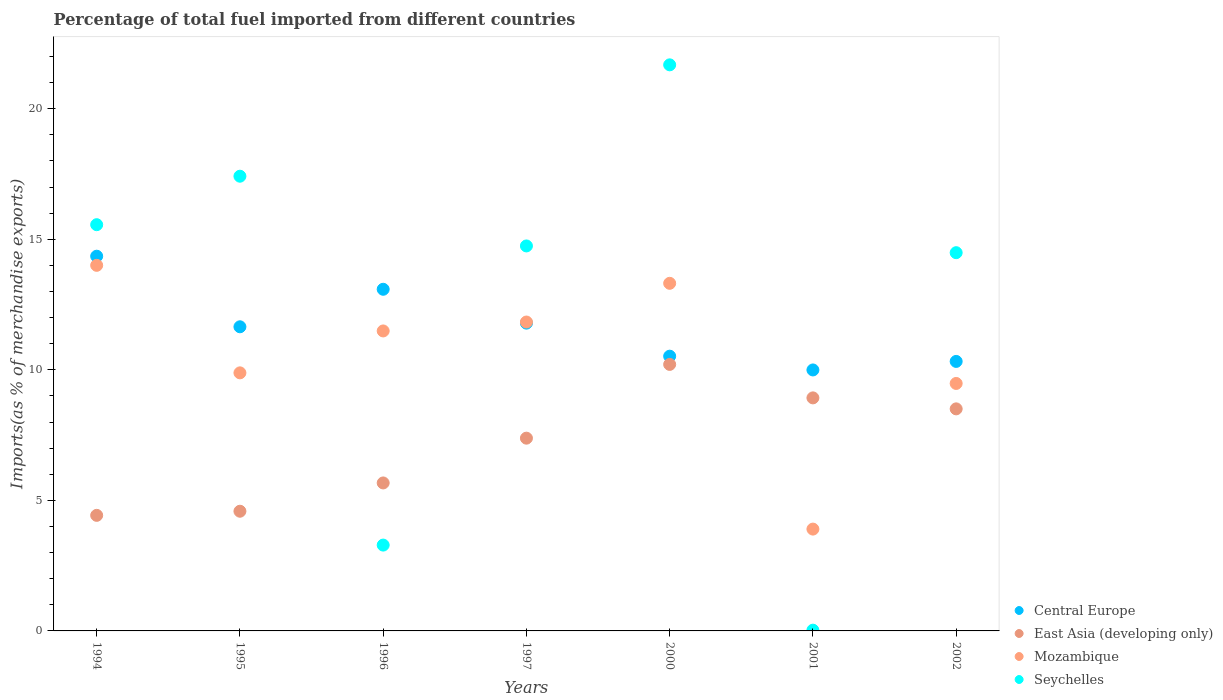How many different coloured dotlines are there?
Offer a very short reply. 4. What is the percentage of imports to different countries in Seychelles in 1997?
Offer a very short reply. 14.74. Across all years, what is the maximum percentage of imports to different countries in Mozambique?
Give a very brief answer. 14. Across all years, what is the minimum percentage of imports to different countries in East Asia (developing only)?
Provide a short and direct response. 4.43. In which year was the percentage of imports to different countries in Mozambique maximum?
Offer a terse response. 1994. In which year was the percentage of imports to different countries in Mozambique minimum?
Offer a terse response. 2001. What is the total percentage of imports to different countries in Mozambique in the graph?
Your answer should be very brief. 73.89. What is the difference between the percentage of imports to different countries in East Asia (developing only) in 1994 and that in 1997?
Keep it short and to the point. -2.96. What is the difference between the percentage of imports to different countries in Mozambique in 1995 and the percentage of imports to different countries in East Asia (developing only) in 1996?
Provide a short and direct response. 4.22. What is the average percentage of imports to different countries in Seychelles per year?
Make the answer very short. 12.46. In the year 1997, what is the difference between the percentage of imports to different countries in Seychelles and percentage of imports to different countries in Central Europe?
Offer a very short reply. 2.96. In how many years, is the percentage of imports to different countries in Central Europe greater than 21 %?
Keep it short and to the point. 0. What is the ratio of the percentage of imports to different countries in Central Europe in 1994 to that in 2002?
Your response must be concise. 1.39. What is the difference between the highest and the second highest percentage of imports to different countries in East Asia (developing only)?
Give a very brief answer. 1.28. What is the difference between the highest and the lowest percentage of imports to different countries in Central Europe?
Make the answer very short. 4.36. In how many years, is the percentage of imports to different countries in Central Europe greater than the average percentage of imports to different countries in Central Europe taken over all years?
Provide a succinct answer. 3. Is the percentage of imports to different countries in Seychelles strictly greater than the percentage of imports to different countries in East Asia (developing only) over the years?
Provide a succinct answer. No. How many dotlines are there?
Ensure brevity in your answer.  4. How many years are there in the graph?
Provide a short and direct response. 7. Does the graph contain any zero values?
Your response must be concise. No. Does the graph contain grids?
Make the answer very short. No. How many legend labels are there?
Your answer should be very brief. 4. What is the title of the graph?
Your answer should be very brief. Percentage of total fuel imported from different countries. What is the label or title of the Y-axis?
Provide a succinct answer. Imports(as % of merchandise exports). What is the Imports(as % of merchandise exports) of Central Europe in 1994?
Offer a terse response. 14.35. What is the Imports(as % of merchandise exports) in East Asia (developing only) in 1994?
Offer a very short reply. 4.43. What is the Imports(as % of merchandise exports) of Mozambique in 1994?
Your answer should be compact. 14. What is the Imports(as % of merchandise exports) of Seychelles in 1994?
Provide a short and direct response. 15.56. What is the Imports(as % of merchandise exports) of Central Europe in 1995?
Your response must be concise. 11.65. What is the Imports(as % of merchandise exports) in East Asia (developing only) in 1995?
Provide a short and direct response. 4.58. What is the Imports(as % of merchandise exports) in Mozambique in 1995?
Make the answer very short. 9.88. What is the Imports(as % of merchandise exports) of Seychelles in 1995?
Your answer should be very brief. 17.41. What is the Imports(as % of merchandise exports) of Central Europe in 1996?
Offer a terse response. 13.08. What is the Imports(as % of merchandise exports) of East Asia (developing only) in 1996?
Offer a terse response. 5.67. What is the Imports(as % of merchandise exports) of Mozambique in 1996?
Provide a succinct answer. 11.49. What is the Imports(as % of merchandise exports) of Seychelles in 1996?
Your answer should be very brief. 3.29. What is the Imports(as % of merchandise exports) of Central Europe in 1997?
Offer a very short reply. 11.79. What is the Imports(as % of merchandise exports) in East Asia (developing only) in 1997?
Your response must be concise. 7.38. What is the Imports(as % of merchandise exports) in Mozambique in 1997?
Provide a short and direct response. 11.83. What is the Imports(as % of merchandise exports) in Seychelles in 1997?
Keep it short and to the point. 14.74. What is the Imports(as % of merchandise exports) in Central Europe in 2000?
Your response must be concise. 10.52. What is the Imports(as % of merchandise exports) of East Asia (developing only) in 2000?
Ensure brevity in your answer.  10.21. What is the Imports(as % of merchandise exports) in Mozambique in 2000?
Keep it short and to the point. 13.31. What is the Imports(as % of merchandise exports) in Seychelles in 2000?
Offer a terse response. 21.68. What is the Imports(as % of merchandise exports) in Central Europe in 2001?
Provide a short and direct response. 9.99. What is the Imports(as % of merchandise exports) of East Asia (developing only) in 2001?
Ensure brevity in your answer.  8.93. What is the Imports(as % of merchandise exports) in Mozambique in 2001?
Offer a terse response. 3.9. What is the Imports(as % of merchandise exports) of Seychelles in 2001?
Provide a short and direct response. 0.03. What is the Imports(as % of merchandise exports) of Central Europe in 2002?
Your answer should be compact. 10.32. What is the Imports(as % of merchandise exports) in East Asia (developing only) in 2002?
Give a very brief answer. 8.5. What is the Imports(as % of merchandise exports) in Mozambique in 2002?
Your answer should be very brief. 9.48. What is the Imports(as % of merchandise exports) in Seychelles in 2002?
Provide a short and direct response. 14.49. Across all years, what is the maximum Imports(as % of merchandise exports) of Central Europe?
Offer a terse response. 14.35. Across all years, what is the maximum Imports(as % of merchandise exports) of East Asia (developing only)?
Give a very brief answer. 10.21. Across all years, what is the maximum Imports(as % of merchandise exports) of Mozambique?
Ensure brevity in your answer.  14. Across all years, what is the maximum Imports(as % of merchandise exports) of Seychelles?
Keep it short and to the point. 21.68. Across all years, what is the minimum Imports(as % of merchandise exports) of Central Europe?
Your answer should be very brief. 9.99. Across all years, what is the minimum Imports(as % of merchandise exports) of East Asia (developing only)?
Give a very brief answer. 4.43. Across all years, what is the minimum Imports(as % of merchandise exports) of Mozambique?
Your answer should be very brief. 3.9. Across all years, what is the minimum Imports(as % of merchandise exports) in Seychelles?
Your response must be concise. 0.03. What is the total Imports(as % of merchandise exports) of Central Europe in the graph?
Your response must be concise. 81.71. What is the total Imports(as % of merchandise exports) of East Asia (developing only) in the graph?
Ensure brevity in your answer.  49.7. What is the total Imports(as % of merchandise exports) of Mozambique in the graph?
Ensure brevity in your answer.  73.89. What is the total Imports(as % of merchandise exports) of Seychelles in the graph?
Your answer should be compact. 87.2. What is the difference between the Imports(as % of merchandise exports) of Central Europe in 1994 and that in 1995?
Ensure brevity in your answer.  2.7. What is the difference between the Imports(as % of merchandise exports) in East Asia (developing only) in 1994 and that in 1995?
Provide a succinct answer. -0.16. What is the difference between the Imports(as % of merchandise exports) of Mozambique in 1994 and that in 1995?
Provide a succinct answer. 4.12. What is the difference between the Imports(as % of merchandise exports) in Seychelles in 1994 and that in 1995?
Provide a succinct answer. -1.86. What is the difference between the Imports(as % of merchandise exports) of Central Europe in 1994 and that in 1996?
Your response must be concise. 1.27. What is the difference between the Imports(as % of merchandise exports) in East Asia (developing only) in 1994 and that in 1996?
Provide a short and direct response. -1.24. What is the difference between the Imports(as % of merchandise exports) of Mozambique in 1994 and that in 1996?
Ensure brevity in your answer.  2.51. What is the difference between the Imports(as % of merchandise exports) of Seychelles in 1994 and that in 1996?
Your answer should be compact. 12.27. What is the difference between the Imports(as % of merchandise exports) in Central Europe in 1994 and that in 1997?
Your answer should be very brief. 2.56. What is the difference between the Imports(as % of merchandise exports) in East Asia (developing only) in 1994 and that in 1997?
Provide a succinct answer. -2.96. What is the difference between the Imports(as % of merchandise exports) of Mozambique in 1994 and that in 1997?
Offer a terse response. 2.17. What is the difference between the Imports(as % of merchandise exports) of Seychelles in 1994 and that in 1997?
Offer a terse response. 0.81. What is the difference between the Imports(as % of merchandise exports) of Central Europe in 1994 and that in 2000?
Your answer should be very brief. 3.83. What is the difference between the Imports(as % of merchandise exports) in East Asia (developing only) in 1994 and that in 2000?
Your response must be concise. -5.78. What is the difference between the Imports(as % of merchandise exports) in Mozambique in 1994 and that in 2000?
Your answer should be very brief. 0.69. What is the difference between the Imports(as % of merchandise exports) of Seychelles in 1994 and that in 2000?
Provide a short and direct response. -6.12. What is the difference between the Imports(as % of merchandise exports) in Central Europe in 1994 and that in 2001?
Make the answer very short. 4.36. What is the difference between the Imports(as % of merchandise exports) in East Asia (developing only) in 1994 and that in 2001?
Keep it short and to the point. -4.5. What is the difference between the Imports(as % of merchandise exports) in Mozambique in 1994 and that in 2001?
Provide a short and direct response. 10.1. What is the difference between the Imports(as % of merchandise exports) in Seychelles in 1994 and that in 2001?
Offer a terse response. 15.53. What is the difference between the Imports(as % of merchandise exports) of Central Europe in 1994 and that in 2002?
Keep it short and to the point. 4.03. What is the difference between the Imports(as % of merchandise exports) of East Asia (developing only) in 1994 and that in 2002?
Provide a succinct answer. -4.08. What is the difference between the Imports(as % of merchandise exports) of Mozambique in 1994 and that in 2002?
Make the answer very short. 4.52. What is the difference between the Imports(as % of merchandise exports) in Seychelles in 1994 and that in 2002?
Give a very brief answer. 1.07. What is the difference between the Imports(as % of merchandise exports) of Central Europe in 1995 and that in 1996?
Keep it short and to the point. -1.44. What is the difference between the Imports(as % of merchandise exports) of East Asia (developing only) in 1995 and that in 1996?
Offer a terse response. -1.08. What is the difference between the Imports(as % of merchandise exports) of Mozambique in 1995 and that in 1996?
Keep it short and to the point. -1.6. What is the difference between the Imports(as % of merchandise exports) of Seychelles in 1995 and that in 1996?
Give a very brief answer. 14.13. What is the difference between the Imports(as % of merchandise exports) in Central Europe in 1995 and that in 1997?
Your answer should be very brief. -0.14. What is the difference between the Imports(as % of merchandise exports) in East Asia (developing only) in 1995 and that in 1997?
Provide a succinct answer. -2.8. What is the difference between the Imports(as % of merchandise exports) in Mozambique in 1995 and that in 1997?
Offer a very short reply. -1.95. What is the difference between the Imports(as % of merchandise exports) in Seychelles in 1995 and that in 1997?
Provide a succinct answer. 2.67. What is the difference between the Imports(as % of merchandise exports) of Central Europe in 1995 and that in 2000?
Ensure brevity in your answer.  1.13. What is the difference between the Imports(as % of merchandise exports) in East Asia (developing only) in 1995 and that in 2000?
Your answer should be compact. -5.62. What is the difference between the Imports(as % of merchandise exports) of Mozambique in 1995 and that in 2000?
Offer a very short reply. -3.43. What is the difference between the Imports(as % of merchandise exports) in Seychelles in 1995 and that in 2000?
Your answer should be compact. -4.27. What is the difference between the Imports(as % of merchandise exports) in Central Europe in 1995 and that in 2001?
Offer a terse response. 1.65. What is the difference between the Imports(as % of merchandise exports) of East Asia (developing only) in 1995 and that in 2001?
Provide a succinct answer. -4.34. What is the difference between the Imports(as % of merchandise exports) of Mozambique in 1995 and that in 2001?
Give a very brief answer. 5.98. What is the difference between the Imports(as % of merchandise exports) of Seychelles in 1995 and that in 2001?
Offer a terse response. 17.39. What is the difference between the Imports(as % of merchandise exports) in Central Europe in 1995 and that in 2002?
Offer a terse response. 1.33. What is the difference between the Imports(as % of merchandise exports) of East Asia (developing only) in 1995 and that in 2002?
Ensure brevity in your answer.  -3.92. What is the difference between the Imports(as % of merchandise exports) in Mozambique in 1995 and that in 2002?
Offer a very short reply. 0.41. What is the difference between the Imports(as % of merchandise exports) of Seychelles in 1995 and that in 2002?
Ensure brevity in your answer.  2.93. What is the difference between the Imports(as % of merchandise exports) of Central Europe in 1996 and that in 1997?
Your response must be concise. 1.3. What is the difference between the Imports(as % of merchandise exports) of East Asia (developing only) in 1996 and that in 1997?
Your answer should be compact. -1.71. What is the difference between the Imports(as % of merchandise exports) in Mozambique in 1996 and that in 1997?
Ensure brevity in your answer.  -0.34. What is the difference between the Imports(as % of merchandise exports) in Seychelles in 1996 and that in 1997?
Provide a succinct answer. -11.46. What is the difference between the Imports(as % of merchandise exports) in Central Europe in 1996 and that in 2000?
Offer a very short reply. 2.56. What is the difference between the Imports(as % of merchandise exports) of East Asia (developing only) in 1996 and that in 2000?
Give a very brief answer. -4.54. What is the difference between the Imports(as % of merchandise exports) of Mozambique in 1996 and that in 2000?
Ensure brevity in your answer.  -1.82. What is the difference between the Imports(as % of merchandise exports) of Seychelles in 1996 and that in 2000?
Your response must be concise. -18.39. What is the difference between the Imports(as % of merchandise exports) of Central Europe in 1996 and that in 2001?
Offer a terse response. 3.09. What is the difference between the Imports(as % of merchandise exports) of East Asia (developing only) in 1996 and that in 2001?
Your response must be concise. -3.26. What is the difference between the Imports(as % of merchandise exports) in Mozambique in 1996 and that in 2001?
Provide a short and direct response. 7.59. What is the difference between the Imports(as % of merchandise exports) of Seychelles in 1996 and that in 2001?
Ensure brevity in your answer.  3.26. What is the difference between the Imports(as % of merchandise exports) in Central Europe in 1996 and that in 2002?
Provide a succinct answer. 2.76. What is the difference between the Imports(as % of merchandise exports) in East Asia (developing only) in 1996 and that in 2002?
Offer a very short reply. -2.84. What is the difference between the Imports(as % of merchandise exports) in Mozambique in 1996 and that in 2002?
Give a very brief answer. 2.01. What is the difference between the Imports(as % of merchandise exports) in Seychelles in 1996 and that in 2002?
Give a very brief answer. -11.2. What is the difference between the Imports(as % of merchandise exports) in Central Europe in 1997 and that in 2000?
Offer a terse response. 1.27. What is the difference between the Imports(as % of merchandise exports) in East Asia (developing only) in 1997 and that in 2000?
Offer a very short reply. -2.82. What is the difference between the Imports(as % of merchandise exports) of Mozambique in 1997 and that in 2000?
Provide a succinct answer. -1.48. What is the difference between the Imports(as % of merchandise exports) of Seychelles in 1997 and that in 2000?
Provide a short and direct response. -6.94. What is the difference between the Imports(as % of merchandise exports) in Central Europe in 1997 and that in 2001?
Your response must be concise. 1.79. What is the difference between the Imports(as % of merchandise exports) of East Asia (developing only) in 1997 and that in 2001?
Give a very brief answer. -1.54. What is the difference between the Imports(as % of merchandise exports) in Mozambique in 1997 and that in 2001?
Keep it short and to the point. 7.93. What is the difference between the Imports(as % of merchandise exports) in Seychelles in 1997 and that in 2001?
Your answer should be very brief. 14.72. What is the difference between the Imports(as % of merchandise exports) in Central Europe in 1997 and that in 2002?
Provide a short and direct response. 1.47. What is the difference between the Imports(as % of merchandise exports) of East Asia (developing only) in 1997 and that in 2002?
Your response must be concise. -1.12. What is the difference between the Imports(as % of merchandise exports) in Mozambique in 1997 and that in 2002?
Your answer should be compact. 2.35. What is the difference between the Imports(as % of merchandise exports) of Seychelles in 1997 and that in 2002?
Make the answer very short. 0.26. What is the difference between the Imports(as % of merchandise exports) of Central Europe in 2000 and that in 2001?
Your response must be concise. 0.53. What is the difference between the Imports(as % of merchandise exports) of East Asia (developing only) in 2000 and that in 2001?
Offer a very short reply. 1.28. What is the difference between the Imports(as % of merchandise exports) of Mozambique in 2000 and that in 2001?
Offer a terse response. 9.41. What is the difference between the Imports(as % of merchandise exports) of Seychelles in 2000 and that in 2001?
Your answer should be very brief. 21.65. What is the difference between the Imports(as % of merchandise exports) in Central Europe in 2000 and that in 2002?
Give a very brief answer. 0.2. What is the difference between the Imports(as % of merchandise exports) in East Asia (developing only) in 2000 and that in 2002?
Provide a succinct answer. 1.7. What is the difference between the Imports(as % of merchandise exports) in Mozambique in 2000 and that in 2002?
Your response must be concise. 3.84. What is the difference between the Imports(as % of merchandise exports) of Seychelles in 2000 and that in 2002?
Provide a succinct answer. 7.19. What is the difference between the Imports(as % of merchandise exports) of Central Europe in 2001 and that in 2002?
Provide a short and direct response. -0.33. What is the difference between the Imports(as % of merchandise exports) of East Asia (developing only) in 2001 and that in 2002?
Your answer should be compact. 0.42. What is the difference between the Imports(as % of merchandise exports) of Mozambique in 2001 and that in 2002?
Provide a succinct answer. -5.58. What is the difference between the Imports(as % of merchandise exports) of Seychelles in 2001 and that in 2002?
Your answer should be compact. -14.46. What is the difference between the Imports(as % of merchandise exports) of Central Europe in 1994 and the Imports(as % of merchandise exports) of East Asia (developing only) in 1995?
Offer a very short reply. 9.77. What is the difference between the Imports(as % of merchandise exports) in Central Europe in 1994 and the Imports(as % of merchandise exports) in Mozambique in 1995?
Offer a very short reply. 4.47. What is the difference between the Imports(as % of merchandise exports) in Central Europe in 1994 and the Imports(as % of merchandise exports) in Seychelles in 1995?
Your answer should be very brief. -3.06. What is the difference between the Imports(as % of merchandise exports) of East Asia (developing only) in 1994 and the Imports(as % of merchandise exports) of Mozambique in 1995?
Offer a very short reply. -5.46. What is the difference between the Imports(as % of merchandise exports) in East Asia (developing only) in 1994 and the Imports(as % of merchandise exports) in Seychelles in 1995?
Give a very brief answer. -12.99. What is the difference between the Imports(as % of merchandise exports) of Mozambique in 1994 and the Imports(as % of merchandise exports) of Seychelles in 1995?
Give a very brief answer. -3.41. What is the difference between the Imports(as % of merchandise exports) of Central Europe in 1994 and the Imports(as % of merchandise exports) of East Asia (developing only) in 1996?
Offer a very short reply. 8.68. What is the difference between the Imports(as % of merchandise exports) in Central Europe in 1994 and the Imports(as % of merchandise exports) in Mozambique in 1996?
Your response must be concise. 2.86. What is the difference between the Imports(as % of merchandise exports) of Central Europe in 1994 and the Imports(as % of merchandise exports) of Seychelles in 1996?
Your response must be concise. 11.06. What is the difference between the Imports(as % of merchandise exports) in East Asia (developing only) in 1994 and the Imports(as % of merchandise exports) in Mozambique in 1996?
Provide a short and direct response. -7.06. What is the difference between the Imports(as % of merchandise exports) of East Asia (developing only) in 1994 and the Imports(as % of merchandise exports) of Seychelles in 1996?
Ensure brevity in your answer.  1.14. What is the difference between the Imports(as % of merchandise exports) in Mozambique in 1994 and the Imports(as % of merchandise exports) in Seychelles in 1996?
Your response must be concise. 10.71. What is the difference between the Imports(as % of merchandise exports) in Central Europe in 1994 and the Imports(as % of merchandise exports) in East Asia (developing only) in 1997?
Provide a succinct answer. 6.97. What is the difference between the Imports(as % of merchandise exports) in Central Europe in 1994 and the Imports(as % of merchandise exports) in Mozambique in 1997?
Provide a short and direct response. 2.52. What is the difference between the Imports(as % of merchandise exports) of Central Europe in 1994 and the Imports(as % of merchandise exports) of Seychelles in 1997?
Offer a terse response. -0.39. What is the difference between the Imports(as % of merchandise exports) in East Asia (developing only) in 1994 and the Imports(as % of merchandise exports) in Mozambique in 1997?
Keep it short and to the point. -7.4. What is the difference between the Imports(as % of merchandise exports) in East Asia (developing only) in 1994 and the Imports(as % of merchandise exports) in Seychelles in 1997?
Give a very brief answer. -10.32. What is the difference between the Imports(as % of merchandise exports) of Mozambique in 1994 and the Imports(as % of merchandise exports) of Seychelles in 1997?
Your answer should be compact. -0.74. What is the difference between the Imports(as % of merchandise exports) of Central Europe in 1994 and the Imports(as % of merchandise exports) of East Asia (developing only) in 2000?
Your answer should be very brief. 4.14. What is the difference between the Imports(as % of merchandise exports) in Central Europe in 1994 and the Imports(as % of merchandise exports) in Mozambique in 2000?
Offer a very short reply. 1.04. What is the difference between the Imports(as % of merchandise exports) of Central Europe in 1994 and the Imports(as % of merchandise exports) of Seychelles in 2000?
Make the answer very short. -7.33. What is the difference between the Imports(as % of merchandise exports) in East Asia (developing only) in 1994 and the Imports(as % of merchandise exports) in Mozambique in 2000?
Give a very brief answer. -8.89. What is the difference between the Imports(as % of merchandise exports) of East Asia (developing only) in 1994 and the Imports(as % of merchandise exports) of Seychelles in 2000?
Your response must be concise. -17.25. What is the difference between the Imports(as % of merchandise exports) of Mozambique in 1994 and the Imports(as % of merchandise exports) of Seychelles in 2000?
Make the answer very short. -7.68. What is the difference between the Imports(as % of merchandise exports) of Central Europe in 1994 and the Imports(as % of merchandise exports) of East Asia (developing only) in 2001?
Your answer should be compact. 5.43. What is the difference between the Imports(as % of merchandise exports) of Central Europe in 1994 and the Imports(as % of merchandise exports) of Mozambique in 2001?
Offer a very short reply. 10.45. What is the difference between the Imports(as % of merchandise exports) of Central Europe in 1994 and the Imports(as % of merchandise exports) of Seychelles in 2001?
Ensure brevity in your answer.  14.32. What is the difference between the Imports(as % of merchandise exports) of East Asia (developing only) in 1994 and the Imports(as % of merchandise exports) of Mozambique in 2001?
Offer a very short reply. 0.53. What is the difference between the Imports(as % of merchandise exports) of East Asia (developing only) in 1994 and the Imports(as % of merchandise exports) of Seychelles in 2001?
Make the answer very short. 4.4. What is the difference between the Imports(as % of merchandise exports) in Mozambique in 1994 and the Imports(as % of merchandise exports) in Seychelles in 2001?
Provide a succinct answer. 13.97. What is the difference between the Imports(as % of merchandise exports) of Central Europe in 1994 and the Imports(as % of merchandise exports) of East Asia (developing only) in 2002?
Make the answer very short. 5.85. What is the difference between the Imports(as % of merchandise exports) in Central Europe in 1994 and the Imports(as % of merchandise exports) in Mozambique in 2002?
Provide a short and direct response. 4.87. What is the difference between the Imports(as % of merchandise exports) in Central Europe in 1994 and the Imports(as % of merchandise exports) in Seychelles in 2002?
Offer a terse response. -0.13. What is the difference between the Imports(as % of merchandise exports) of East Asia (developing only) in 1994 and the Imports(as % of merchandise exports) of Mozambique in 2002?
Your answer should be compact. -5.05. What is the difference between the Imports(as % of merchandise exports) of East Asia (developing only) in 1994 and the Imports(as % of merchandise exports) of Seychelles in 2002?
Your response must be concise. -10.06. What is the difference between the Imports(as % of merchandise exports) in Mozambique in 1994 and the Imports(as % of merchandise exports) in Seychelles in 2002?
Your response must be concise. -0.48. What is the difference between the Imports(as % of merchandise exports) of Central Europe in 1995 and the Imports(as % of merchandise exports) of East Asia (developing only) in 1996?
Make the answer very short. 5.98. What is the difference between the Imports(as % of merchandise exports) in Central Europe in 1995 and the Imports(as % of merchandise exports) in Mozambique in 1996?
Ensure brevity in your answer.  0.16. What is the difference between the Imports(as % of merchandise exports) of Central Europe in 1995 and the Imports(as % of merchandise exports) of Seychelles in 1996?
Give a very brief answer. 8.36. What is the difference between the Imports(as % of merchandise exports) of East Asia (developing only) in 1995 and the Imports(as % of merchandise exports) of Mozambique in 1996?
Keep it short and to the point. -6.9. What is the difference between the Imports(as % of merchandise exports) of East Asia (developing only) in 1995 and the Imports(as % of merchandise exports) of Seychelles in 1996?
Your answer should be compact. 1.3. What is the difference between the Imports(as % of merchandise exports) in Mozambique in 1995 and the Imports(as % of merchandise exports) in Seychelles in 1996?
Give a very brief answer. 6.6. What is the difference between the Imports(as % of merchandise exports) in Central Europe in 1995 and the Imports(as % of merchandise exports) in East Asia (developing only) in 1997?
Make the answer very short. 4.27. What is the difference between the Imports(as % of merchandise exports) in Central Europe in 1995 and the Imports(as % of merchandise exports) in Mozambique in 1997?
Give a very brief answer. -0.18. What is the difference between the Imports(as % of merchandise exports) of Central Europe in 1995 and the Imports(as % of merchandise exports) of Seychelles in 1997?
Make the answer very short. -3.1. What is the difference between the Imports(as % of merchandise exports) of East Asia (developing only) in 1995 and the Imports(as % of merchandise exports) of Mozambique in 1997?
Offer a terse response. -7.25. What is the difference between the Imports(as % of merchandise exports) in East Asia (developing only) in 1995 and the Imports(as % of merchandise exports) in Seychelles in 1997?
Keep it short and to the point. -10.16. What is the difference between the Imports(as % of merchandise exports) of Mozambique in 1995 and the Imports(as % of merchandise exports) of Seychelles in 1997?
Offer a terse response. -4.86. What is the difference between the Imports(as % of merchandise exports) of Central Europe in 1995 and the Imports(as % of merchandise exports) of East Asia (developing only) in 2000?
Keep it short and to the point. 1.44. What is the difference between the Imports(as % of merchandise exports) in Central Europe in 1995 and the Imports(as % of merchandise exports) in Mozambique in 2000?
Keep it short and to the point. -1.66. What is the difference between the Imports(as % of merchandise exports) of Central Europe in 1995 and the Imports(as % of merchandise exports) of Seychelles in 2000?
Give a very brief answer. -10.03. What is the difference between the Imports(as % of merchandise exports) of East Asia (developing only) in 1995 and the Imports(as % of merchandise exports) of Mozambique in 2000?
Your answer should be compact. -8.73. What is the difference between the Imports(as % of merchandise exports) in East Asia (developing only) in 1995 and the Imports(as % of merchandise exports) in Seychelles in 2000?
Provide a succinct answer. -17.1. What is the difference between the Imports(as % of merchandise exports) of Mozambique in 1995 and the Imports(as % of merchandise exports) of Seychelles in 2000?
Make the answer very short. -11.8. What is the difference between the Imports(as % of merchandise exports) in Central Europe in 1995 and the Imports(as % of merchandise exports) in East Asia (developing only) in 2001?
Ensure brevity in your answer.  2.72. What is the difference between the Imports(as % of merchandise exports) in Central Europe in 1995 and the Imports(as % of merchandise exports) in Mozambique in 2001?
Provide a succinct answer. 7.75. What is the difference between the Imports(as % of merchandise exports) of Central Europe in 1995 and the Imports(as % of merchandise exports) of Seychelles in 2001?
Keep it short and to the point. 11.62. What is the difference between the Imports(as % of merchandise exports) in East Asia (developing only) in 1995 and the Imports(as % of merchandise exports) in Mozambique in 2001?
Keep it short and to the point. 0.68. What is the difference between the Imports(as % of merchandise exports) in East Asia (developing only) in 1995 and the Imports(as % of merchandise exports) in Seychelles in 2001?
Keep it short and to the point. 4.55. What is the difference between the Imports(as % of merchandise exports) of Mozambique in 1995 and the Imports(as % of merchandise exports) of Seychelles in 2001?
Offer a very short reply. 9.85. What is the difference between the Imports(as % of merchandise exports) in Central Europe in 1995 and the Imports(as % of merchandise exports) in East Asia (developing only) in 2002?
Your answer should be very brief. 3.14. What is the difference between the Imports(as % of merchandise exports) in Central Europe in 1995 and the Imports(as % of merchandise exports) in Mozambique in 2002?
Offer a very short reply. 2.17. What is the difference between the Imports(as % of merchandise exports) of Central Europe in 1995 and the Imports(as % of merchandise exports) of Seychelles in 2002?
Your response must be concise. -2.84. What is the difference between the Imports(as % of merchandise exports) of East Asia (developing only) in 1995 and the Imports(as % of merchandise exports) of Mozambique in 2002?
Ensure brevity in your answer.  -4.89. What is the difference between the Imports(as % of merchandise exports) of East Asia (developing only) in 1995 and the Imports(as % of merchandise exports) of Seychelles in 2002?
Your response must be concise. -9.9. What is the difference between the Imports(as % of merchandise exports) in Mozambique in 1995 and the Imports(as % of merchandise exports) in Seychelles in 2002?
Provide a short and direct response. -4.6. What is the difference between the Imports(as % of merchandise exports) in Central Europe in 1996 and the Imports(as % of merchandise exports) in East Asia (developing only) in 1997?
Your response must be concise. 5.7. What is the difference between the Imports(as % of merchandise exports) of Central Europe in 1996 and the Imports(as % of merchandise exports) of Mozambique in 1997?
Give a very brief answer. 1.25. What is the difference between the Imports(as % of merchandise exports) in Central Europe in 1996 and the Imports(as % of merchandise exports) in Seychelles in 1997?
Provide a short and direct response. -1.66. What is the difference between the Imports(as % of merchandise exports) in East Asia (developing only) in 1996 and the Imports(as % of merchandise exports) in Mozambique in 1997?
Provide a short and direct response. -6.16. What is the difference between the Imports(as % of merchandise exports) in East Asia (developing only) in 1996 and the Imports(as % of merchandise exports) in Seychelles in 1997?
Your response must be concise. -9.08. What is the difference between the Imports(as % of merchandise exports) in Mozambique in 1996 and the Imports(as % of merchandise exports) in Seychelles in 1997?
Keep it short and to the point. -3.26. What is the difference between the Imports(as % of merchandise exports) in Central Europe in 1996 and the Imports(as % of merchandise exports) in East Asia (developing only) in 2000?
Keep it short and to the point. 2.88. What is the difference between the Imports(as % of merchandise exports) of Central Europe in 1996 and the Imports(as % of merchandise exports) of Mozambique in 2000?
Offer a very short reply. -0.23. What is the difference between the Imports(as % of merchandise exports) in Central Europe in 1996 and the Imports(as % of merchandise exports) in Seychelles in 2000?
Keep it short and to the point. -8.6. What is the difference between the Imports(as % of merchandise exports) in East Asia (developing only) in 1996 and the Imports(as % of merchandise exports) in Mozambique in 2000?
Provide a succinct answer. -7.65. What is the difference between the Imports(as % of merchandise exports) in East Asia (developing only) in 1996 and the Imports(as % of merchandise exports) in Seychelles in 2000?
Offer a very short reply. -16.01. What is the difference between the Imports(as % of merchandise exports) in Mozambique in 1996 and the Imports(as % of merchandise exports) in Seychelles in 2000?
Give a very brief answer. -10.19. What is the difference between the Imports(as % of merchandise exports) in Central Europe in 1996 and the Imports(as % of merchandise exports) in East Asia (developing only) in 2001?
Your answer should be very brief. 4.16. What is the difference between the Imports(as % of merchandise exports) in Central Europe in 1996 and the Imports(as % of merchandise exports) in Mozambique in 2001?
Provide a short and direct response. 9.18. What is the difference between the Imports(as % of merchandise exports) of Central Europe in 1996 and the Imports(as % of merchandise exports) of Seychelles in 2001?
Ensure brevity in your answer.  13.06. What is the difference between the Imports(as % of merchandise exports) in East Asia (developing only) in 1996 and the Imports(as % of merchandise exports) in Mozambique in 2001?
Offer a terse response. 1.77. What is the difference between the Imports(as % of merchandise exports) in East Asia (developing only) in 1996 and the Imports(as % of merchandise exports) in Seychelles in 2001?
Provide a short and direct response. 5.64. What is the difference between the Imports(as % of merchandise exports) of Mozambique in 1996 and the Imports(as % of merchandise exports) of Seychelles in 2001?
Give a very brief answer. 11.46. What is the difference between the Imports(as % of merchandise exports) of Central Europe in 1996 and the Imports(as % of merchandise exports) of East Asia (developing only) in 2002?
Your response must be concise. 4.58. What is the difference between the Imports(as % of merchandise exports) of Central Europe in 1996 and the Imports(as % of merchandise exports) of Mozambique in 2002?
Offer a very short reply. 3.61. What is the difference between the Imports(as % of merchandise exports) of Central Europe in 1996 and the Imports(as % of merchandise exports) of Seychelles in 2002?
Provide a short and direct response. -1.4. What is the difference between the Imports(as % of merchandise exports) in East Asia (developing only) in 1996 and the Imports(as % of merchandise exports) in Mozambique in 2002?
Your response must be concise. -3.81. What is the difference between the Imports(as % of merchandise exports) in East Asia (developing only) in 1996 and the Imports(as % of merchandise exports) in Seychelles in 2002?
Provide a short and direct response. -8.82. What is the difference between the Imports(as % of merchandise exports) in Mozambique in 1996 and the Imports(as % of merchandise exports) in Seychelles in 2002?
Make the answer very short. -3. What is the difference between the Imports(as % of merchandise exports) of Central Europe in 1997 and the Imports(as % of merchandise exports) of East Asia (developing only) in 2000?
Offer a very short reply. 1.58. What is the difference between the Imports(as % of merchandise exports) of Central Europe in 1997 and the Imports(as % of merchandise exports) of Mozambique in 2000?
Provide a short and direct response. -1.52. What is the difference between the Imports(as % of merchandise exports) of Central Europe in 1997 and the Imports(as % of merchandise exports) of Seychelles in 2000?
Make the answer very short. -9.89. What is the difference between the Imports(as % of merchandise exports) in East Asia (developing only) in 1997 and the Imports(as % of merchandise exports) in Mozambique in 2000?
Offer a terse response. -5.93. What is the difference between the Imports(as % of merchandise exports) in East Asia (developing only) in 1997 and the Imports(as % of merchandise exports) in Seychelles in 2000?
Your answer should be very brief. -14.3. What is the difference between the Imports(as % of merchandise exports) of Mozambique in 1997 and the Imports(as % of merchandise exports) of Seychelles in 2000?
Your response must be concise. -9.85. What is the difference between the Imports(as % of merchandise exports) of Central Europe in 1997 and the Imports(as % of merchandise exports) of East Asia (developing only) in 2001?
Your answer should be very brief. 2.86. What is the difference between the Imports(as % of merchandise exports) of Central Europe in 1997 and the Imports(as % of merchandise exports) of Mozambique in 2001?
Offer a terse response. 7.89. What is the difference between the Imports(as % of merchandise exports) in Central Europe in 1997 and the Imports(as % of merchandise exports) in Seychelles in 2001?
Ensure brevity in your answer.  11.76. What is the difference between the Imports(as % of merchandise exports) of East Asia (developing only) in 1997 and the Imports(as % of merchandise exports) of Mozambique in 2001?
Your response must be concise. 3.48. What is the difference between the Imports(as % of merchandise exports) in East Asia (developing only) in 1997 and the Imports(as % of merchandise exports) in Seychelles in 2001?
Keep it short and to the point. 7.35. What is the difference between the Imports(as % of merchandise exports) of Mozambique in 1997 and the Imports(as % of merchandise exports) of Seychelles in 2001?
Give a very brief answer. 11.8. What is the difference between the Imports(as % of merchandise exports) in Central Europe in 1997 and the Imports(as % of merchandise exports) in East Asia (developing only) in 2002?
Give a very brief answer. 3.28. What is the difference between the Imports(as % of merchandise exports) of Central Europe in 1997 and the Imports(as % of merchandise exports) of Mozambique in 2002?
Provide a succinct answer. 2.31. What is the difference between the Imports(as % of merchandise exports) in Central Europe in 1997 and the Imports(as % of merchandise exports) in Seychelles in 2002?
Make the answer very short. -2.7. What is the difference between the Imports(as % of merchandise exports) in East Asia (developing only) in 1997 and the Imports(as % of merchandise exports) in Mozambique in 2002?
Offer a terse response. -2.1. What is the difference between the Imports(as % of merchandise exports) in East Asia (developing only) in 1997 and the Imports(as % of merchandise exports) in Seychelles in 2002?
Offer a very short reply. -7.1. What is the difference between the Imports(as % of merchandise exports) in Mozambique in 1997 and the Imports(as % of merchandise exports) in Seychelles in 2002?
Provide a succinct answer. -2.66. What is the difference between the Imports(as % of merchandise exports) in Central Europe in 2000 and the Imports(as % of merchandise exports) in East Asia (developing only) in 2001?
Offer a very short reply. 1.6. What is the difference between the Imports(as % of merchandise exports) of Central Europe in 2000 and the Imports(as % of merchandise exports) of Mozambique in 2001?
Offer a terse response. 6.62. What is the difference between the Imports(as % of merchandise exports) of Central Europe in 2000 and the Imports(as % of merchandise exports) of Seychelles in 2001?
Keep it short and to the point. 10.49. What is the difference between the Imports(as % of merchandise exports) in East Asia (developing only) in 2000 and the Imports(as % of merchandise exports) in Mozambique in 2001?
Make the answer very short. 6.31. What is the difference between the Imports(as % of merchandise exports) of East Asia (developing only) in 2000 and the Imports(as % of merchandise exports) of Seychelles in 2001?
Offer a very short reply. 10.18. What is the difference between the Imports(as % of merchandise exports) in Mozambique in 2000 and the Imports(as % of merchandise exports) in Seychelles in 2001?
Make the answer very short. 13.28. What is the difference between the Imports(as % of merchandise exports) of Central Europe in 2000 and the Imports(as % of merchandise exports) of East Asia (developing only) in 2002?
Provide a succinct answer. 2.02. What is the difference between the Imports(as % of merchandise exports) of Central Europe in 2000 and the Imports(as % of merchandise exports) of Mozambique in 2002?
Offer a very short reply. 1.04. What is the difference between the Imports(as % of merchandise exports) in Central Europe in 2000 and the Imports(as % of merchandise exports) in Seychelles in 2002?
Provide a succinct answer. -3.96. What is the difference between the Imports(as % of merchandise exports) in East Asia (developing only) in 2000 and the Imports(as % of merchandise exports) in Mozambique in 2002?
Provide a succinct answer. 0.73. What is the difference between the Imports(as % of merchandise exports) in East Asia (developing only) in 2000 and the Imports(as % of merchandise exports) in Seychelles in 2002?
Ensure brevity in your answer.  -4.28. What is the difference between the Imports(as % of merchandise exports) in Mozambique in 2000 and the Imports(as % of merchandise exports) in Seychelles in 2002?
Your answer should be compact. -1.17. What is the difference between the Imports(as % of merchandise exports) of Central Europe in 2001 and the Imports(as % of merchandise exports) of East Asia (developing only) in 2002?
Provide a succinct answer. 1.49. What is the difference between the Imports(as % of merchandise exports) in Central Europe in 2001 and the Imports(as % of merchandise exports) in Mozambique in 2002?
Your response must be concise. 0.52. What is the difference between the Imports(as % of merchandise exports) of Central Europe in 2001 and the Imports(as % of merchandise exports) of Seychelles in 2002?
Your response must be concise. -4.49. What is the difference between the Imports(as % of merchandise exports) of East Asia (developing only) in 2001 and the Imports(as % of merchandise exports) of Mozambique in 2002?
Offer a very short reply. -0.55. What is the difference between the Imports(as % of merchandise exports) of East Asia (developing only) in 2001 and the Imports(as % of merchandise exports) of Seychelles in 2002?
Give a very brief answer. -5.56. What is the difference between the Imports(as % of merchandise exports) of Mozambique in 2001 and the Imports(as % of merchandise exports) of Seychelles in 2002?
Your answer should be compact. -10.59. What is the average Imports(as % of merchandise exports) of Central Europe per year?
Your answer should be compact. 11.67. What is the average Imports(as % of merchandise exports) in East Asia (developing only) per year?
Your answer should be compact. 7.1. What is the average Imports(as % of merchandise exports) in Mozambique per year?
Make the answer very short. 10.56. What is the average Imports(as % of merchandise exports) of Seychelles per year?
Offer a terse response. 12.46. In the year 1994, what is the difference between the Imports(as % of merchandise exports) in Central Europe and Imports(as % of merchandise exports) in East Asia (developing only)?
Keep it short and to the point. 9.92. In the year 1994, what is the difference between the Imports(as % of merchandise exports) in Central Europe and Imports(as % of merchandise exports) in Mozambique?
Keep it short and to the point. 0.35. In the year 1994, what is the difference between the Imports(as % of merchandise exports) in Central Europe and Imports(as % of merchandise exports) in Seychelles?
Give a very brief answer. -1.21. In the year 1994, what is the difference between the Imports(as % of merchandise exports) in East Asia (developing only) and Imports(as % of merchandise exports) in Mozambique?
Ensure brevity in your answer.  -9.58. In the year 1994, what is the difference between the Imports(as % of merchandise exports) in East Asia (developing only) and Imports(as % of merchandise exports) in Seychelles?
Make the answer very short. -11.13. In the year 1994, what is the difference between the Imports(as % of merchandise exports) in Mozambique and Imports(as % of merchandise exports) in Seychelles?
Provide a short and direct response. -1.56. In the year 1995, what is the difference between the Imports(as % of merchandise exports) in Central Europe and Imports(as % of merchandise exports) in East Asia (developing only)?
Make the answer very short. 7.06. In the year 1995, what is the difference between the Imports(as % of merchandise exports) in Central Europe and Imports(as % of merchandise exports) in Mozambique?
Make the answer very short. 1.76. In the year 1995, what is the difference between the Imports(as % of merchandise exports) in Central Europe and Imports(as % of merchandise exports) in Seychelles?
Your answer should be compact. -5.77. In the year 1995, what is the difference between the Imports(as % of merchandise exports) of East Asia (developing only) and Imports(as % of merchandise exports) of Mozambique?
Your response must be concise. -5.3. In the year 1995, what is the difference between the Imports(as % of merchandise exports) of East Asia (developing only) and Imports(as % of merchandise exports) of Seychelles?
Ensure brevity in your answer.  -12.83. In the year 1995, what is the difference between the Imports(as % of merchandise exports) in Mozambique and Imports(as % of merchandise exports) in Seychelles?
Give a very brief answer. -7.53. In the year 1996, what is the difference between the Imports(as % of merchandise exports) in Central Europe and Imports(as % of merchandise exports) in East Asia (developing only)?
Your answer should be very brief. 7.42. In the year 1996, what is the difference between the Imports(as % of merchandise exports) of Central Europe and Imports(as % of merchandise exports) of Mozambique?
Offer a very short reply. 1.6. In the year 1996, what is the difference between the Imports(as % of merchandise exports) in Central Europe and Imports(as % of merchandise exports) in Seychelles?
Provide a succinct answer. 9.8. In the year 1996, what is the difference between the Imports(as % of merchandise exports) in East Asia (developing only) and Imports(as % of merchandise exports) in Mozambique?
Make the answer very short. -5.82. In the year 1996, what is the difference between the Imports(as % of merchandise exports) of East Asia (developing only) and Imports(as % of merchandise exports) of Seychelles?
Provide a short and direct response. 2.38. In the year 1996, what is the difference between the Imports(as % of merchandise exports) of Mozambique and Imports(as % of merchandise exports) of Seychelles?
Your answer should be compact. 8.2. In the year 1997, what is the difference between the Imports(as % of merchandise exports) in Central Europe and Imports(as % of merchandise exports) in East Asia (developing only)?
Provide a succinct answer. 4.41. In the year 1997, what is the difference between the Imports(as % of merchandise exports) in Central Europe and Imports(as % of merchandise exports) in Mozambique?
Offer a terse response. -0.04. In the year 1997, what is the difference between the Imports(as % of merchandise exports) in Central Europe and Imports(as % of merchandise exports) in Seychelles?
Keep it short and to the point. -2.96. In the year 1997, what is the difference between the Imports(as % of merchandise exports) in East Asia (developing only) and Imports(as % of merchandise exports) in Mozambique?
Provide a short and direct response. -4.45. In the year 1997, what is the difference between the Imports(as % of merchandise exports) in East Asia (developing only) and Imports(as % of merchandise exports) in Seychelles?
Your answer should be compact. -7.36. In the year 1997, what is the difference between the Imports(as % of merchandise exports) of Mozambique and Imports(as % of merchandise exports) of Seychelles?
Offer a terse response. -2.91. In the year 2000, what is the difference between the Imports(as % of merchandise exports) of Central Europe and Imports(as % of merchandise exports) of East Asia (developing only)?
Make the answer very short. 0.32. In the year 2000, what is the difference between the Imports(as % of merchandise exports) in Central Europe and Imports(as % of merchandise exports) in Mozambique?
Your answer should be very brief. -2.79. In the year 2000, what is the difference between the Imports(as % of merchandise exports) of Central Europe and Imports(as % of merchandise exports) of Seychelles?
Provide a short and direct response. -11.16. In the year 2000, what is the difference between the Imports(as % of merchandise exports) of East Asia (developing only) and Imports(as % of merchandise exports) of Mozambique?
Give a very brief answer. -3.11. In the year 2000, what is the difference between the Imports(as % of merchandise exports) of East Asia (developing only) and Imports(as % of merchandise exports) of Seychelles?
Provide a short and direct response. -11.47. In the year 2000, what is the difference between the Imports(as % of merchandise exports) of Mozambique and Imports(as % of merchandise exports) of Seychelles?
Make the answer very short. -8.37. In the year 2001, what is the difference between the Imports(as % of merchandise exports) in Central Europe and Imports(as % of merchandise exports) in East Asia (developing only)?
Give a very brief answer. 1.07. In the year 2001, what is the difference between the Imports(as % of merchandise exports) in Central Europe and Imports(as % of merchandise exports) in Mozambique?
Give a very brief answer. 6.1. In the year 2001, what is the difference between the Imports(as % of merchandise exports) of Central Europe and Imports(as % of merchandise exports) of Seychelles?
Your response must be concise. 9.97. In the year 2001, what is the difference between the Imports(as % of merchandise exports) in East Asia (developing only) and Imports(as % of merchandise exports) in Mozambique?
Give a very brief answer. 5.03. In the year 2001, what is the difference between the Imports(as % of merchandise exports) in East Asia (developing only) and Imports(as % of merchandise exports) in Seychelles?
Your response must be concise. 8.9. In the year 2001, what is the difference between the Imports(as % of merchandise exports) in Mozambique and Imports(as % of merchandise exports) in Seychelles?
Your response must be concise. 3.87. In the year 2002, what is the difference between the Imports(as % of merchandise exports) in Central Europe and Imports(as % of merchandise exports) in East Asia (developing only)?
Your answer should be very brief. 1.82. In the year 2002, what is the difference between the Imports(as % of merchandise exports) of Central Europe and Imports(as % of merchandise exports) of Mozambique?
Your answer should be compact. 0.84. In the year 2002, what is the difference between the Imports(as % of merchandise exports) of Central Europe and Imports(as % of merchandise exports) of Seychelles?
Your answer should be compact. -4.16. In the year 2002, what is the difference between the Imports(as % of merchandise exports) of East Asia (developing only) and Imports(as % of merchandise exports) of Mozambique?
Your answer should be compact. -0.97. In the year 2002, what is the difference between the Imports(as % of merchandise exports) of East Asia (developing only) and Imports(as % of merchandise exports) of Seychelles?
Your answer should be very brief. -5.98. In the year 2002, what is the difference between the Imports(as % of merchandise exports) of Mozambique and Imports(as % of merchandise exports) of Seychelles?
Ensure brevity in your answer.  -5.01. What is the ratio of the Imports(as % of merchandise exports) in Central Europe in 1994 to that in 1995?
Make the answer very short. 1.23. What is the ratio of the Imports(as % of merchandise exports) of East Asia (developing only) in 1994 to that in 1995?
Offer a very short reply. 0.97. What is the ratio of the Imports(as % of merchandise exports) of Mozambique in 1994 to that in 1995?
Provide a succinct answer. 1.42. What is the ratio of the Imports(as % of merchandise exports) of Seychelles in 1994 to that in 1995?
Make the answer very short. 0.89. What is the ratio of the Imports(as % of merchandise exports) of Central Europe in 1994 to that in 1996?
Your response must be concise. 1.1. What is the ratio of the Imports(as % of merchandise exports) in East Asia (developing only) in 1994 to that in 1996?
Your response must be concise. 0.78. What is the ratio of the Imports(as % of merchandise exports) in Mozambique in 1994 to that in 1996?
Your answer should be very brief. 1.22. What is the ratio of the Imports(as % of merchandise exports) of Seychelles in 1994 to that in 1996?
Offer a very short reply. 4.73. What is the ratio of the Imports(as % of merchandise exports) in Central Europe in 1994 to that in 1997?
Keep it short and to the point. 1.22. What is the ratio of the Imports(as % of merchandise exports) in East Asia (developing only) in 1994 to that in 1997?
Provide a short and direct response. 0.6. What is the ratio of the Imports(as % of merchandise exports) of Mozambique in 1994 to that in 1997?
Your answer should be very brief. 1.18. What is the ratio of the Imports(as % of merchandise exports) of Seychelles in 1994 to that in 1997?
Give a very brief answer. 1.06. What is the ratio of the Imports(as % of merchandise exports) in Central Europe in 1994 to that in 2000?
Provide a succinct answer. 1.36. What is the ratio of the Imports(as % of merchandise exports) of East Asia (developing only) in 1994 to that in 2000?
Give a very brief answer. 0.43. What is the ratio of the Imports(as % of merchandise exports) of Mozambique in 1994 to that in 2000?
Provide a succinct answer. 1.05. What is the ratio of the Imports(as % of merchandise exports) of Seychelles in 1994 to that in 2000?
Make the answer very short. 0.72. What is the ratio of the Imports(as % of merchandise exports) in Central Europe in 1994 to that in 2001?
Keep it short and to the point. 1.44. What is the ratio of the Imports(as % of merchandise exports) of East Asia (developing only) in 1994 to that in 2001?
Your response must be concise. 0.5. What is the ratio of the Imports(as % of merchandise exports) in Mozambique in 1994 to that in 2001?
Give a very brief answer. 3.59. What is the ratio of the Imports(as % of merchandise exports) in Seychelles in 1994 to that in 2001?
Provide a short and direct response. 536.76. What is the ratio of the Imports(as % of merchandise exports) in Central Europe in 1994 to that in 2002?
Offer a very short reply. 1.39. What is the ratio of the Imports(as % of merchandise exports) in East Asia (developing only) in 1994 to that in 2002?
Provide a succinct answer. 0.52. What is the ratio of the Imports(as % of merchandise exports) in Mozambique in 1994 to that in 2002?
Your answer should be compact. 1.48. What is the ratio of the Imports(as % of merchandise exports) in Seychelles in 1994 to that in 2002?
Make the answer very short. 1.07. What is the ratio of the Imports(as % of merchandise exports) in Central Europe in 1995 to that in 1996?
Your answer should be compact. 0.89. What is the ratio of the Imports(as % of merchandise exports) of East Asia (developing only) in 1995 to that in 1996?
Offer a terse response. 0.81. What is the ratio of the Imports(as % of merchandise exports) in Mozambique in 1995 to that in 1996?
Ensure brevity in your answer.  0.86. What is the ratio of the Imports(as % of merchandise exports) of Seychelles in 1995 to that in 1996?
Your answer should be very brief. 5.3. What is the ratio of the Imports(as % of merchandise exports) of Central Europe in 1995 to that in 1997?
Your response must be concise. 0.99. What is the ratio of the Imports(as % of merchandise exports) in East Asia (developing only) in 1995 to that in 1997?
Your answer should be very brief. 0.62. What is the ratio of the Imports(as % of merchandise exports) in Mozambique in 1995 to that in 1997?
Your answer should be very brief. 0.84. What is the ratio of the Imports(as % of merchandise exports) in Seychelles in 1995 to that in 1997?
Give a very brief answer. 1.18. What is the ratio of the Imports(as % of merchandise exports) in Central Europe in 1995 to that in 2000?
Give a very brief answer. 1.11. What is the ratio of the Imports(as % of merchandise exports) of East Asia (developing only) in 1995 to that in 2000?
Provide a succinct answer. 0.45. What is the ratio of the Imports(as % of merchandise exports) of Mozambique in 1995 to that in 2000?
Keep it short and to the point. 0.74. What is the ratio of the Imports(as % of merchandise exports) of Seychelles in 1995 to that in 2000?
Offer a very short reply. 0.8. What is the ratio of the Imports(as % of merchandise exports) of Central Europe in 1995 to that in 2001?
Your answer should be very brief. 1.17. What is the ratio of the Imports(as % of merchandise exports) of East Asia (developing only) in 1995 to that in 2001?
Offer a terse response. 0.51. What is the ratio of the Imports(as % of merchandise exports) of Mozambique in 1995 to that in 2001?
Offer a very short reply. 2.53. What is the ratio of the Imports(as % of merchandise exports) of Seychelles in 1995 to that in 2001?
Offer a terse response. 600.81. What is the ratio of the Imports(as % of merchandise exports) in Central Europe in 1995 to that in 2002?
Your answer should be compact. 1.13. What is the ratio of the Imports(as % of merchandise exports) of East Asia (developing only) in 1995 to that in 2002?
Keep it short and to the point. 0.54. What is the ratio of the Imports(as % of merchandise exports) of Mozambique in 1995 to that in 2002?
Make the answer very short. 1.04. What is the ratio of the Imports(as % of merchandise exports) of Seychelles in 1995 to that in 2002?
Give a very brief answer. 1.2. What is the ratio of the Imports(as % of merchandise exports) in Central Europe in 1996 to that in 1997?
Your response must be concise. 1.11. What is the ratio of the Imports(as % of merchandise exports) in East Asia (developing only) in 1996 to that in 1997?
Offer a very short reply. 0.77. What is the ratio of the Imports(as % of merchandise exports) of Mozambique in 1996 to that in 1997?
Offer a very short reply. 0.97. What is the ratio of the Imports(as % of merchandise exports) in Seychelles in 1996 to that in 1997?
Provide a short and direct response. 0.22. What is the ratio of the Imports(as % of merchandise exports) of Central Europe in 1996 to that in 2000?
Ensure brevity in your answer.  1.24. What is the ratio of the Imports(as % of merchandise exports) in East Asia (developing only) in 1996 to that in 2000?
Keep it short and to the point. 0.56. What is the ratio of the Imports(as % of merchandise exports) of Mozambique in 1996 to that in 2000?
Provide a short and direct response. 0.86. What is the ratio of the Imports(as % of merchandise exports) in Seychelles in 1996 to that in 2000?
Give a very brief answer. 0.15. What is the ratio of the Imports(as % of merchandise exports) of Central Europe in 1996 to that in 2001?
Keep it short and to the point. 1.31. What is the ratio of the Imports(as % of merchandise exports) of East Asia (developing only) in 1996 to that in 2001?
Give a very brief answer. 0.64. What is the ratio of the Imports(as % of merchandise exports) in Mozambique in 1996 to that in 2001?
Make the answer very short. 2.95. What is the ratio of the Imports(as % of merchandise exports) in Seychelles in 1996 to that in 2001?
Make the answer very short. 113.41. What is the ratio of the Imports(as % of merchandise exports) in Central Europe in 1996 to that in 2002?
Provide a short and direct response. 1.27. What is the ratio of the Imports(as % of merchandise exports) of East Asia (developing only) in 1996 to that in 2002?
Offer a terse response. 0.67. What is the ratio of the Imports(as % of merchandise exports) in Mozambique in 1996 to that in 2002?
Provide a succinct answer. 1.21. What is the ratio of the Imports(as % of merchandise exports) in Seychelles in 1996 to that in 2002?
Provide a short and direct response. 0.23. What is the ratio of the Imports(as % of merchandise exports) in Central Europe in 1997 to that in 2000?
Provide a succinct answer. 1.12. What is the ratio of the Imports(as % of merchandise exports) in East Asia (developing only) in 1997 to that in 2000?
Provide a short and direct response. 0.72. What is the ratio of the Imports(as % of merchandise exports) in Mozambique in 1997 to that in 2000?
Your answer should be very brief. 0.89. What is the ratio of the Imports(as % of merchandise exports) of Seychelles in 1997 to that in 2000?
Provide a short and direct response. 0.68. What is the ratio of the Imports(as % of merchandise exports) of Central Europe in 1997 to that in 2001?
Keep it short and to the point. 1.18. What is the ratio of the Imports(as % of merchandise exports) in East Asia (developing only) in 1997 to that in 2001?
Your response must be concise. 0.83. What is the ratio of the Imports(as % of merchandise exports) in Mozambique in 1997 to that in 2001?
Your response must be concise. 3.03. What is the ratio of the Imports(as % of merchandise exports) of Seychelles in 1997 to that in 2001?
Offer a terse response. 508.68. What is the ratio of the Imports(as % of merchandise exports) of Central Europe in 1997 to that in 2002?
Your answer should be compact. 1.14. What is the ratio of the Imports(as % of merchandise exports) of East Asia (developing only) in 1997 to that in 2002?
Give a very brief answer. 0.87. What is the ratio of the Imports(as % of merchandise exports) in Mozambique in 1997 to that in 2002?
Your answer should be compact. 1.25. What is the ratio of the Imports(as % of merchandise exports) of Seychelles in 1997 to that in 2002?
Provide a short and direct response. 1.02. What is the ratio of the Imports(as % of merchandise exports) in Central Europe in 2000 to that in 2001?
Your answer should be very brief. 1.05. What is the ratio of the Imports(as % of merchandise exports) in East Asia (developing only) in 2000 to that in 2001?
Your response must be concise. 1.14. What is the ratio of the Imports(as % of merchandise exports) in Mozambique in 2000 to that in 2001?
Your answer should be very brief. 3.41. What is the ratio of the Imports(as % of merchandise exports) of Seychelles in 2000 to that in 2001?
Provide a succinct answer. 747.97. What is the ratio of the Imports(as % of merchandise exports) of Central Europe in 2000 to that in 2002?
Ensure brevity in your answer.  1.02. What is the ratio of the Imports(as % of merchandise exports) in East Asia (developing only) in 2000 to that in 2002?
Your response must be concise. 1.2. What is the ratio of the Imports(as % of merchandise exports) in Mozambique in 2000 to that in 2002?
Give a very brief answer. 1.4. What is the ratio of the Imports(as % of merchandise exports) in Seychelles in 2000 to that in 2002?
Provide a short and direct response. 1.5. What is the ratio of the Imports(as % of merchandise exports) of Central Europe in 2001 to that in 2002?
Offer a very short reply. 0.97. What is the ratio of the Imports(as % of merchandise exports) in East Asia (developing only) in 2001 to that in 2002?
Provide a short and direct response. 1.05. What is the ratio of the Imports(as % of merchandise exports) of Mozambique in 2001 to that in 2002?
Your response must be concise. 0.41. What is the ratio of the Imports(as % of merchandise exports) of Seychelles in 2001 to that in 2002?
Make the answer very short. 0. What is the difference between the highest and the second highest Imports(as % of merchandise exports) of Central Europe?
Provide a short and direct response. 1.27. What is the difference between the highest and the second highest Imports(as % of merchandise exports) of East Asia (developing only)?
Your response must be concise. 1.28. What is the difference between the highest and the second highest Imports(as % of merchandise exports) of Mozambique?
Provide a succinct answer. 0.69. What is the difference between the highest and the second highest Imports(as % of merchandise exports) in Seychelles?
Offer a very short reply. 4.27. What is the difference between the highest and the lowest Imports(as % of merchandise exports) in Central Europe?
Your answer should be compact. 4.36. What is the difference between the highest and the lowest Imports(as % of merchandise exports) of East Asia (developing only)?
Offer a terse response. 5.78. What is the difference between the highest and the lowest Imports(as % of merchandise exports) of Mozambique?
Offer a terse response. 10.1. What is the difference between the highest and the lowest Imports(as % of merchandise exports) of Seychelles?
Your answer should be very brief. 21.65. 